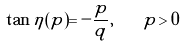<formula> <loc_0><loc_0><loc_500><loc_500>\tan \eta ( p ) = - \frac { p } { q } , \quad p > 0</formula> 